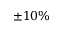Convert formula to latex. <formula><loc_0><loc_0><loc_500><loc_500>\pm 1 0 \%</formula> 